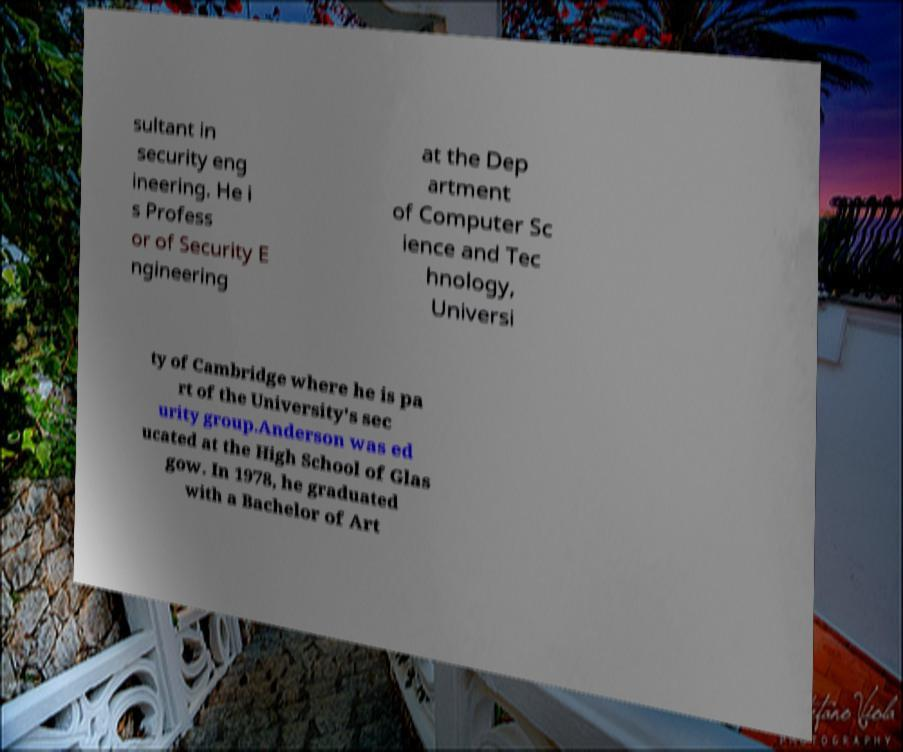Can you read and provide the text displayed in the image?This photo seems to have some interesting text. Can you extract and type it out for me? sultant in security eng ineering. He i s Profess or of Security E ngineering at the Dep artment of Computer Sc ience and Tec hnology, Universi ty of Cambridge where he is pa rt of the University's sec urity group.Anderson was ed ucated at the High School of Glas gow. In 1978, he graduated with a Bachelor of Art 